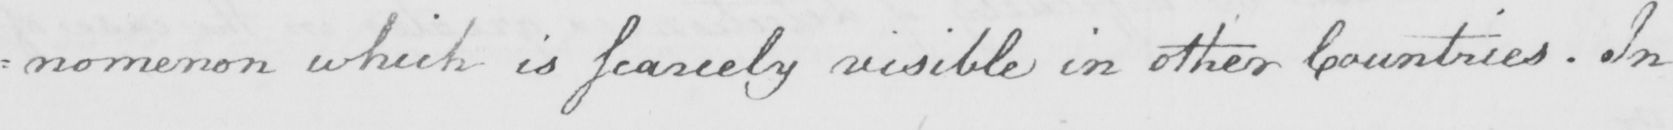Can you tell me what this handwritten text says? : nomenon which is fearcely visible in other Countries . In 